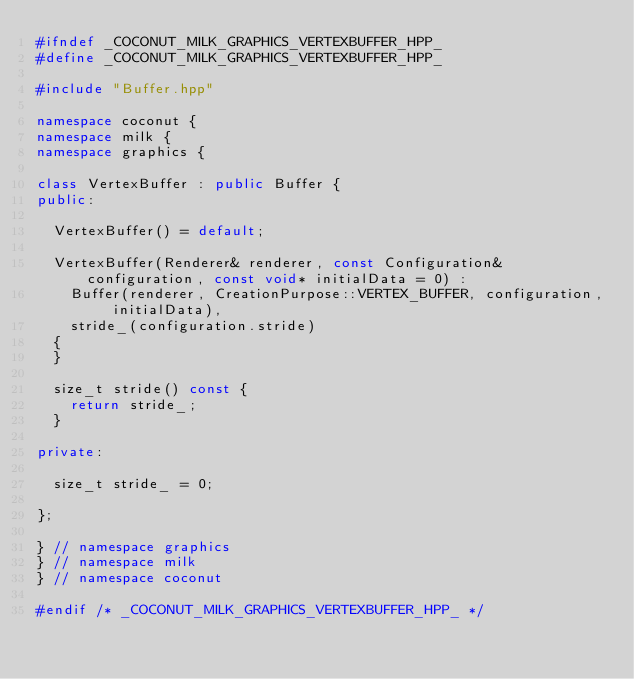<code> <loc_0><loc_0><loc_500><loc_500><_C++_>#ifndef _COCONUT_MILK_GRAPHICS_VERTEXBUFFER_HPP_
#define _COCONUT_MILK_GRAPHICS_VERTEXBUFFER_HPP_

#include "Buffer.hpp"

namespace coconut {
namespace milk {
namespace graphics {

class VertexBuffer : public Buffer {
public:

	VertexBuffer() = default;

	VertexBuffer(Renderer& renderer, const Configuration& configuration, const void* initialData = 0) :
		Buffer(renderer, CreationPurpose::VERTEX_BUFFER, configuration, initialData),
		stride_(configuration.stride)
	{
	}

	size_t stride() const {
		return stride_;
	}

private:

	size_t stride_ = 0;

};

} // namespace graphics
} // namespace milk
} // namespace coconut

#endif /* _COCONUT_MILK_GRAPHICS_VERTEXBUFFER_HPP_ */
</code> 